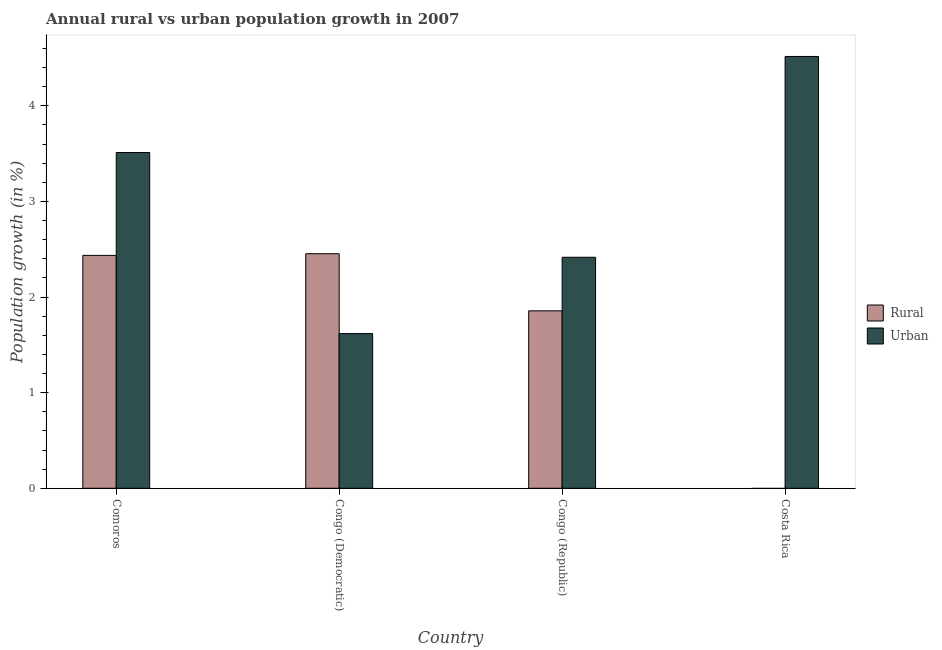How many different coloured bars are there?
Offer a very short reply. 2. Are the number of bars per tick equal to the number of legend labels?
Your response must be concise. No. How many bars are there on the 2nd tick from the right?
Make the answer very short. 2. What is the label of the 4th group of bars from the left?
Give a very brief answer. Costa Rica. What is the rural population growth in Congo (Republic)?
Offer a terse response. 1.86. Across all countries, what is the maximum rural population growth?
Give a very brief answer. 2.45. In which country was the urban population growth maximum?
Your answer should be very brief. Costa Rica. What is the total rural population growth in the graph?
Provide a short and direct response. 6.74. What is the difference between the urban population growth in Comoros and that in Congo (Republic)?
Make the answer very short. 1.1. What is the difference between the urban population growth in Congo (Republic) and the rural population growth in Comoros?
Keep it short and to the point. -0.02. What is the average rural population growth per country?
Provide a succinct answer. 1.69. What is the difference between the urban population growth and rural population growth in Comoros?
Provide a succinct answer. 1.08. What is the ratio of the urban population growth in Congo (Democratic) to that in Congo (Republic)?
Give a very brief answer. 0.67. Is the difference between the rural population growth in Congo (Democratic) and Congo (Republic) greater than the difference between the urban population growth in Congo (Democratic) and Congo (Republic)?
Ensure brevity in your answer.  Yes. What is the difference between the highest and the second highest rural population growth?
Your response must be concise. 0.02. What is the difference between the highest and the lowest urban population growth?
Keep it short and to the point. 2.9. Is the sum of the urban population growth in Congo (Democratic) and Congo (Republic) greater than the maximum rural population growth across all countries?
Ensure brevity in your answer.  Yes. How many bars are there?
Give a very brief answer. 7. What is the difference between two consecutive major ticks on the Y-axis?
Your answer should be compact. 1. Does the graph contain grids?
Keep it short and to the point. No. How many legend labels are there?
Offer a very short reply. 2. How are the legend labels stacked?
Your answer should be very brief. Vertical. What is the title of the graph?
Ensure brevity in your answer.  Annual rural vs urban population growth in 2007. Does "Quasi money growth" appear as one of the legend labels in the graph?
Give a very brief answer. No. What is the label or title of the X-axis?
Offer a very short reply. Country. What is the label or title of the Y-axis?
Your answer should be compact. Population growth (in %). What is the Population growth (in %) of Rural in Comoros?
Give a very brief answer. 2.44. What is the Population growth (in %) of Urban  in Comoros?
Your answer should be compact. 3.51. What is the Population growth (in %) of Rural in Congo (Democratic)?
Your response must be concise. 2.45. What is the Population growth (in %) of Urban  in Congo (Democratic)?
Ensure brevity in your answer.  1.62. What is the Population growth (in %) of Rural in Congo (Republic)?
Offer a very short reply. 1.86. What is the Population growth (in %) of Urban  in Congo (Republic)?
Your response must be concise. 2.42. What is the Population growth (in %) in Rural in Costa Rica?
Your response must be concise. 0. What is the Population growth (in %) in Urban  in Costa Rica?
Offer a terse response. 4.52. Across all countries, what is the maximum Population growth (in %) in Rural?
Your response must be concise. 2.45. Across all countries, what is the maximum Population growth (in %) of Urban ?
Ensure brevity in your answer.  4.52. Across all countries, what is the minimum Population growth (in %) in Urban ?
Ensure brevity in your answer.  1.62. What is the total Population growth (in %) in Rural in the graph?
Offer a terse response. 6.74. What is the total Population growth (in %) of Urban  in the graph?
Your answer should be very brief. 12.06. What is the difference between the Population growth (in %) of Rural in Comoros and that in Congo (Democratic)?
Your answer should be compact. -0.02. What is the difference between the Population growth (in %) in Urban  in Comoros and that in Congo (Democratic)?
Give a very brief answer. 1.89. What is the difference between the Population growth (in %) of Rural in Comoros and that in Congo (Republic)?
Offer a very short reply. 0.58. What is the difference between the Population growth (in %) of Urban  in Comoros and that in Congo (Republic)?
Ensure brevity in your answer.  1.1. What is the difference between the Population growth (in %) of Urban  in Comoros and that in Costa Rica?
Give a very brief answer. -1. What is the difference between the Population growth (in %) of Rural in Congo (Democratic) and that in Congo (Republic)?
Ensure brevity in your answer.  0.6. What is the difference between the Population growth (in %) of Urban  in Congo (Democratic) and that in Congo (Republic)?
Provide a short and direct response. -0.8. What is the difference between the Population growth (in %) in Urban  in Congo (Democratic) and that in Costa Rica?
Provide a short and direct response. -2.9. What is the difference between the Population growth (in %) of Urban  in Congo (Republic) and that in Costa Rica?
Offer a very short reply. -2.1. What is the difference between the Population growth (in %) in Rural in Comoros and the Population growth (in %) in Urban  in Congo (Democratic)?
Offer a terse response. 0.82. What is the difference between the Population growth (in %) in Rural in Comoros and the Population growth (in %) in Urban  in Congo (Republic)?
Your response must be concise. 0.02. What is the difference between the Population growth (in %) in Rural in Comoros and the Population growth (in %) in Urban  in Costa Rica?
Ensure brevity in your answer.  -2.08. What is the difference between the Population growth (in %) of Rural in Congo (Democratic) and the Population growth (in %) of Urban  in Congo (Republic)?
Your answer should be compact. 0.04. What is the difference between the Population growth (in %) in Rural in Congo (Democratic) and the Population growth (in %) in Urban  in Costa Rica?
Ensure brevity in your answer.  -2.06. What is the difference between the Population growth (in %) in Rural in Congo (Republic) and the Population growth (in %) in Urban  in Costa Rica?
Provide a succinct answer. -2.66. What is the average Population growth (in %) of Rural per country?
Provide a short and direct response. 1.69. What is the average Population growth (in %) of Urban  per country?
Your answer should be compact. 3.02. What is the difference between the Population growth (in %) of Rural and Population growth (in %) of Urban  in Comoros?
Offer a terse response. -1.08. What is the difference between the Population growth (in %) of Rural and Population growth (in %) of Urban  in Congo (Democratic)?
Give a very brief answer. 0.83. What is the difference between the Population growth (in %) in Rural and Population growth (in %) in Urban  in Congo (Republic)?
Your response must be concise. -0.56. What is the ratio of the Population growth (in %) of Urban  in Comoros to that in Congo (Democratic)?
Give a very brief answer. 2.17. What is the ratio of the Population growth (in %) of Rural in Comoros to that in Congo (Republic)?
Make the answer very short. 1.31. What is the ratio of the Population growth (in %) of Urban  in Comoros to that in Congo (Republic)?
Provide a succinct answer. 1.45. What is the ratio of the Population growth (in %) of Urban  in Comoros to that in Costa Rica?
Keep it short and to the point. 0.78. What is the ratio of the Population growth (in %) in Rural in Congo (Democratic) to that in Congo (Republic)?
Provide a succinct answer. 1.32. What is the ratio of the Population growth (in %) of Urban  in Congo (Democratic) to that in Congo (Republic)?
Keep it short and to the point. 0.67. What is the ratio of the Population growth (in %) in Urban  in Congo (Democratic) to that in Costa Rica?
Give a very brief answer. 0.36. What is the ratio of the Population growth (in %) in Urban  in Congo (Republic) to that in Costa Rica?
Your response must be concise. 0.54. What is the difference between the highest and the second highest Population growth (in %) in Rural?
Your response must be concise. 0.02. What is the difference between the highest and the second highest Population growth (in %) of Urban ?
Give a very brief answer. 1. What is the difference between the highest and the lowest Population growth (in %) in Rural?
Your answer should be very brief. 2.45. What is the difference between the highest and the lowest Population growth (in %) in Urban ?
Your answer should be compact. 2.9. 